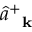<formula> <loc_0><loc_0><loc_500><loc_500>\hat { a } _ { k } ^ { + }</formula> 